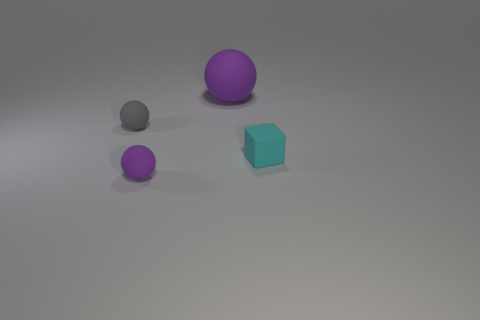How many gray objects are matte cubes or tiny rubber balls?
Keep it short and to the point. 1. There is a tiny rubber thing that is both behind the small purple object and on the left side of the tiny cube; what color is it?
Provide a short and direct response. Gray. Does the small cyan cube that is in front of the big purple matte object have the same material as the tiny thing in front of the matte block?
Offer a terse response. Yes. Is the number of purple matte things left of the tiny gray rubber sphere greater than the number of big matte balls in front of the large rubber sphere?
Your answer should be compact. No. What is the shape of the purple rubber thing that is the same size as the cube?
Keep it short and to the point. Sphere. How many objects are either small cyan objects or small things that are left of the large ball?
Ensure brevity in your answer.  3. Do the big ball and the small cube have the same color?
Ensure brevity in your answer.  No. How many large purple matte spheres are on the left side of the cyan thing?
Ensure brevity in your answer.  1. The large object that is made of the same material as the small gray sphere is what color?
Keep it short and to the point. Purple. What number of shiny things are big red things or small cyan cubes?
Your answer should be compact. 0. 